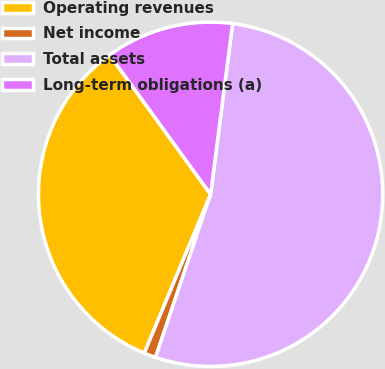Convert chart to OTSL. <chart><loc_0><loc_0><loc_500><loc_500><pie_chart><fcel>Operating revenues<fcel>Net income<fcel>Total assets<fcel>Long-term obligations (a)<nl><fcel>33.73%<fcel>1.11%<fcel>53.14%<fcel>12.02%<nl></chart> 